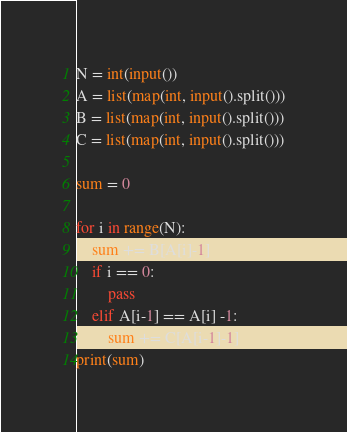<code> <loc_0><loc_0><loc_500><loc_500><_Python_>N = int(input())
A = list(map(int, input().split()))
B = list(map(int, input().split()))
C = list(map(int, input().split()))

sum = 0

for i in range(N):
    sum += B[A[i]-1]
    if i == 0:
        pass
    elif A[i-1] == A[i] -1:
        sum += C[A[i-1]-1]
print(sum)</code> 